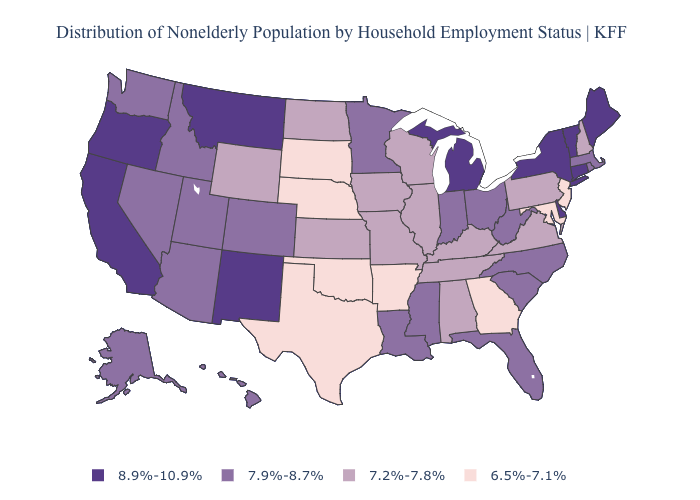Among the states that border Washington , which have the highest value?
Write a very short answer. Oregon. What is the lowest value in the USA?
Keep it brief. 6.5%-7.1%. Name the states that have a value in the range 6.5%-7.1%?
Give a very brief answer. Arkansas, Georgia, Maryland, Nebraska, New Jersey, Oklahoma, South Dakota, Texas. What is the value of Washington?
Concise answer only. 7.9%-8.7%. Name the states that have a value in the range 6.5%-7.1%?
Quick response, please. Arkansas, Georgia, Maryland, Nebraska, New Jersey, Oklahoma, South Dakota, Texas. Name the states that have a value in the range 7.9%-8.7%?
Keep it brief. Alaska, Arizona, Colorado, Florida, Hawaii, Idaho, Indiana, Louisiana, Massachusetts, Minnesota, Mississippi, Nevada, North Carolina, Ohio, Rhode Island, South Carolina, Utah, Washington, West Virginia. What is the value of California?
Short answer required. 8.9%-10.9%. Name the states that have a value in the range 8.9%-10.9%?
Short answer required. California, Connecticut, Delaware, Maine, Michigan, Montana, New Mexico, New York, Oregon, Vermont. Name the states that have a value in the range 7.9%-8.7%?
Quick response, please. Alaska, Arizona, Colorado, Florida, Hawaii, Idaho, Indiana, Louisiana, Massachusetts, Minnesota, Mississippi, Nevada, North Carolina, Ohio, Rhode Island, South Carolina, Utah, Washington, West Virginia. Does West Virginia have a lower value than New York?
Answer briefly. Yes. How many symbols are there in the legend?
Keep it brief. 4. Name the states that have a value in the range 7.9%-8.7%?
Answer briefly. Alaska, Arizona, Colorado, Florida, Hawaii, Idaho, Indiana, Louisiana, Massachusetts, Minnesota, Mississippi, Nevada, North Carolina, Ohio, Rhode Island, South Carolina, Utah, Washington, West Virginia. Name the states that have a value in the range 7.9%-8.7%?
Keep it brief. Alaska, Arizona, Colorado, Florida, Hawaii, Idaho, Indiana, Louisiana, Massachusetts, Minnesota, Mississippi, Nevada, North Carolina, Ohio, Rhode Island, South Carolina, Utah, Washington, West Virginia. Which states hav the highest value in the South?
Write a very short answer. Delaware. 